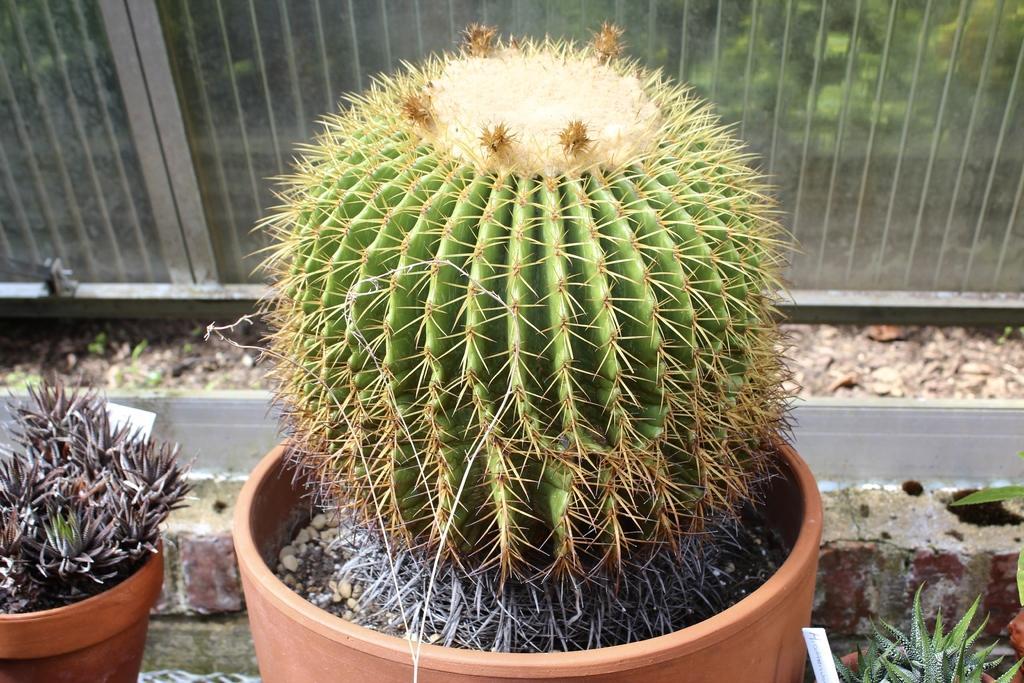In one or two sentences, can you explain what this image depicts? In the foreground of the picture there are plants. In the background there is a railing. Behind the railing, there is greenery. 